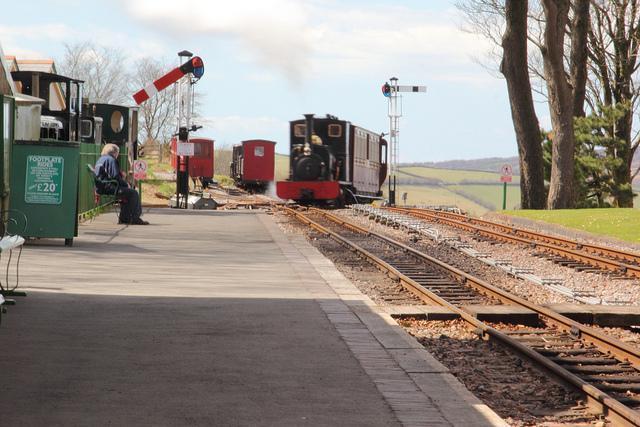What type facility is shown?
Pick the correct solution from the four options below to address the question.
Options: Train race, bus stop, train depot, taxi stand. Train depot. 